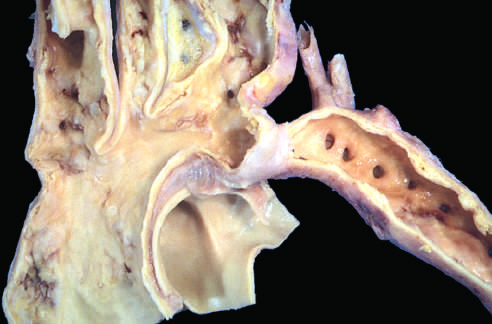where are the dilated ascending aorta and major branch vessels in relation to the coarctation?
Answer the question using a single word or phrase. To the left 